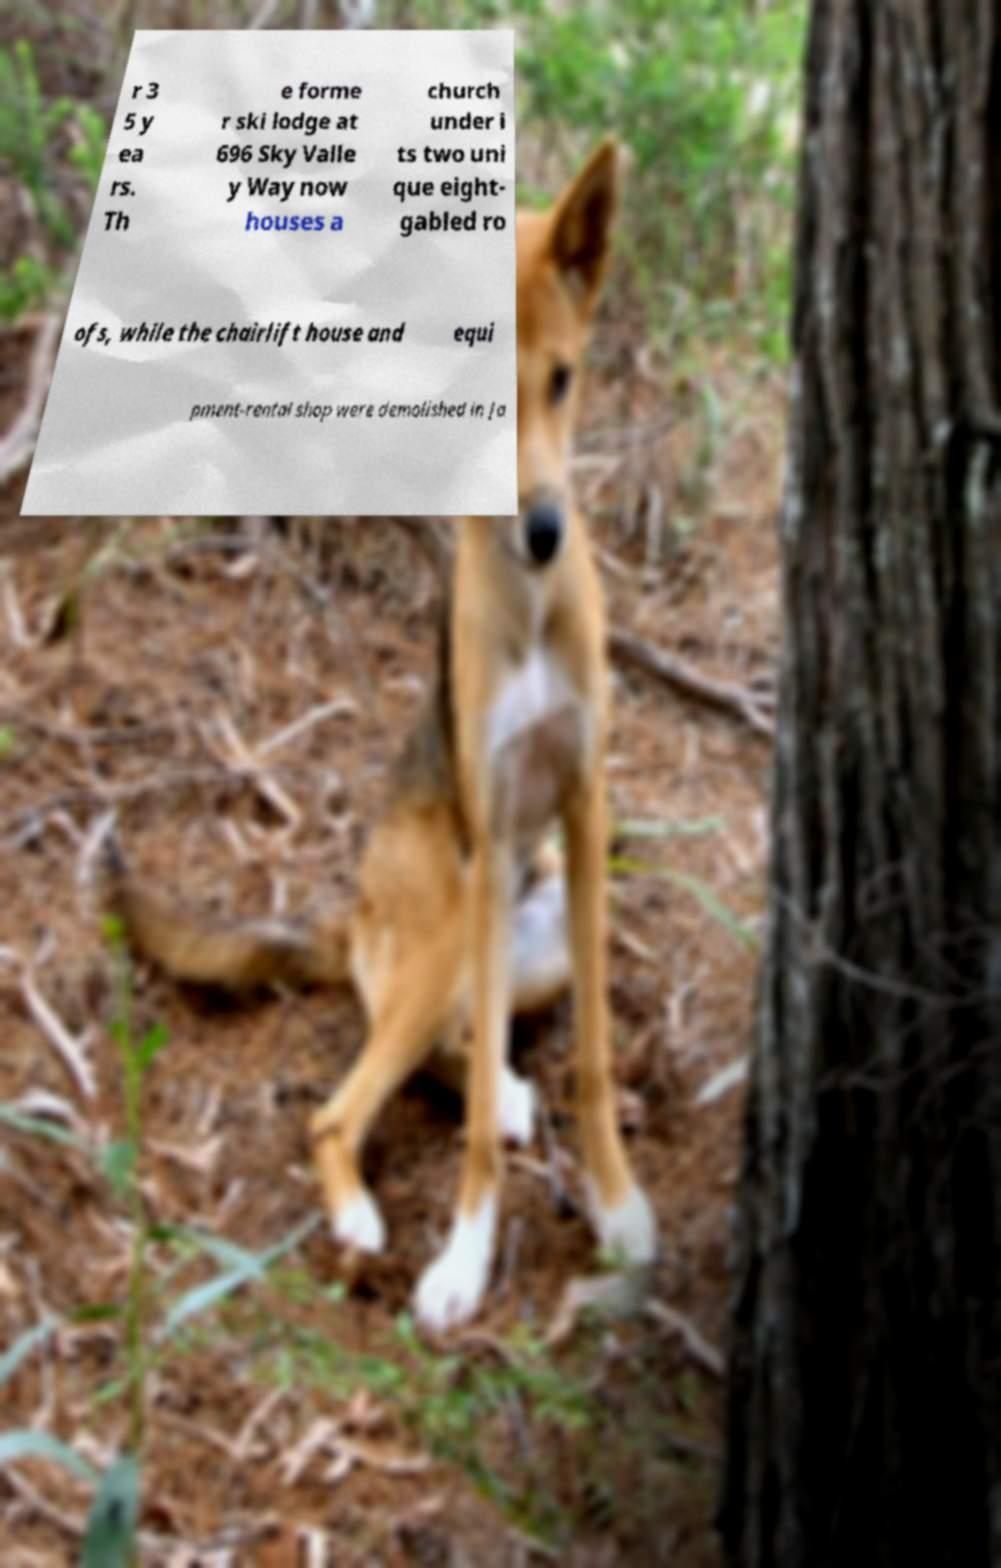For documentation purposes, I need the text within this image transcribed. Could you provide that? r 3 5 y ea rs. Th e forme r ski lodge at 696 Sky Valle y Way now houses a church under i ts two uni que eight- gabled ro ofs, while the chairlift house and equi pment-rental shop were demolished in Ja 